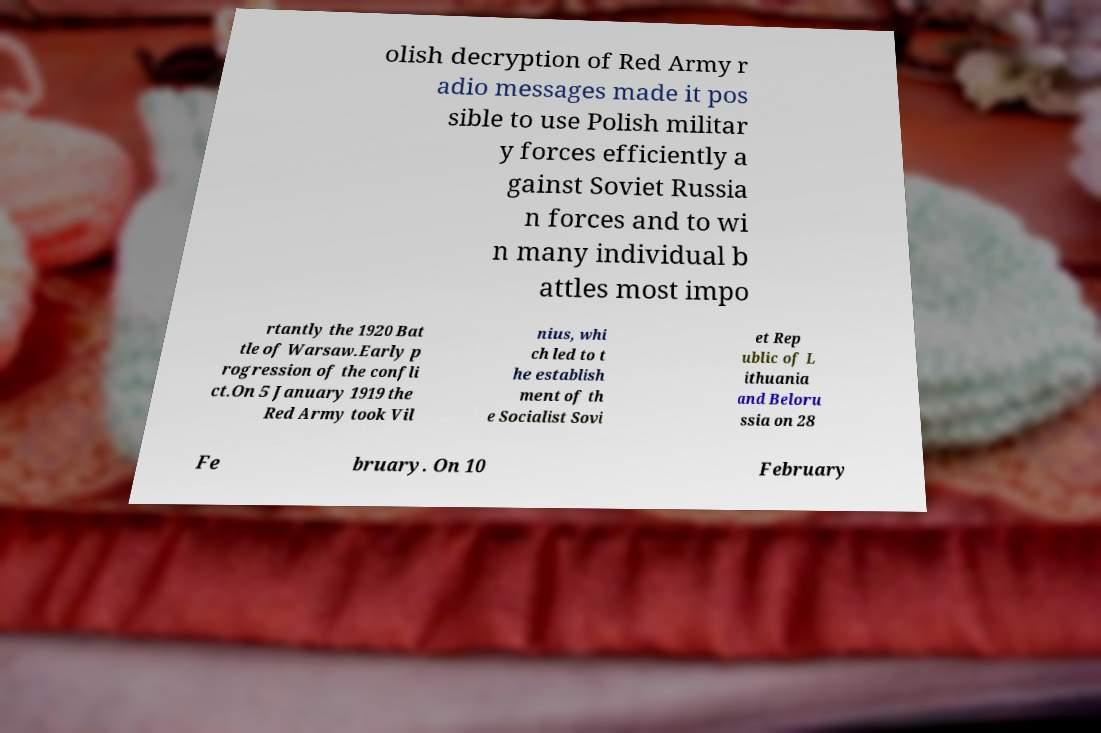Could you assist in decoding the text presented in this image and type it out clearly? olish decryption of Red Army r adio messages made it pos sible to use Polish militar y forces efficiently a gainst Soviet Russia n forces and to wi n many individual b attles most impo rtantly the 1920 Bat tle of Warsaw.Early p rogression of the confli ct.On 5 January 1919 the Red Army took Vil nius, whi ch led to t he establish ment of th e Socialist Sovi et Rep ublic of L ithuania and Beloru ssia on 28 Fe bruary. On 10 February 